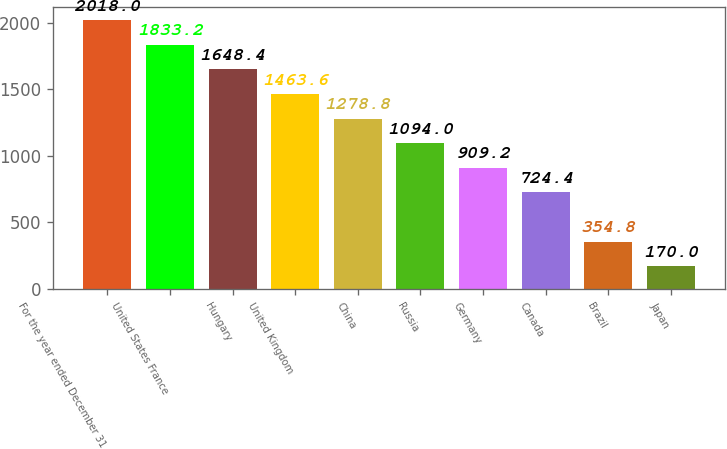Convert chart. <chart><loc_0><loc_0><loc_500><loc_500><bar_chart><fcel>For the year ended December 31<fcel>United States France<fcel>Hungary<fcel>United Kingdom<fcel>China<fcel>Russia<fcel>Germany<fcel>Canada<fcel>Brazil<fcel>Japan<nl><fcel>2018<fcel>1833.2<fcel>1648.4<fcel>1463.6<fcel>1278.8<fcel>1094<fcel>909.2<fcel>724.4<fcel>354.8<fcel>170<nl></chart> 